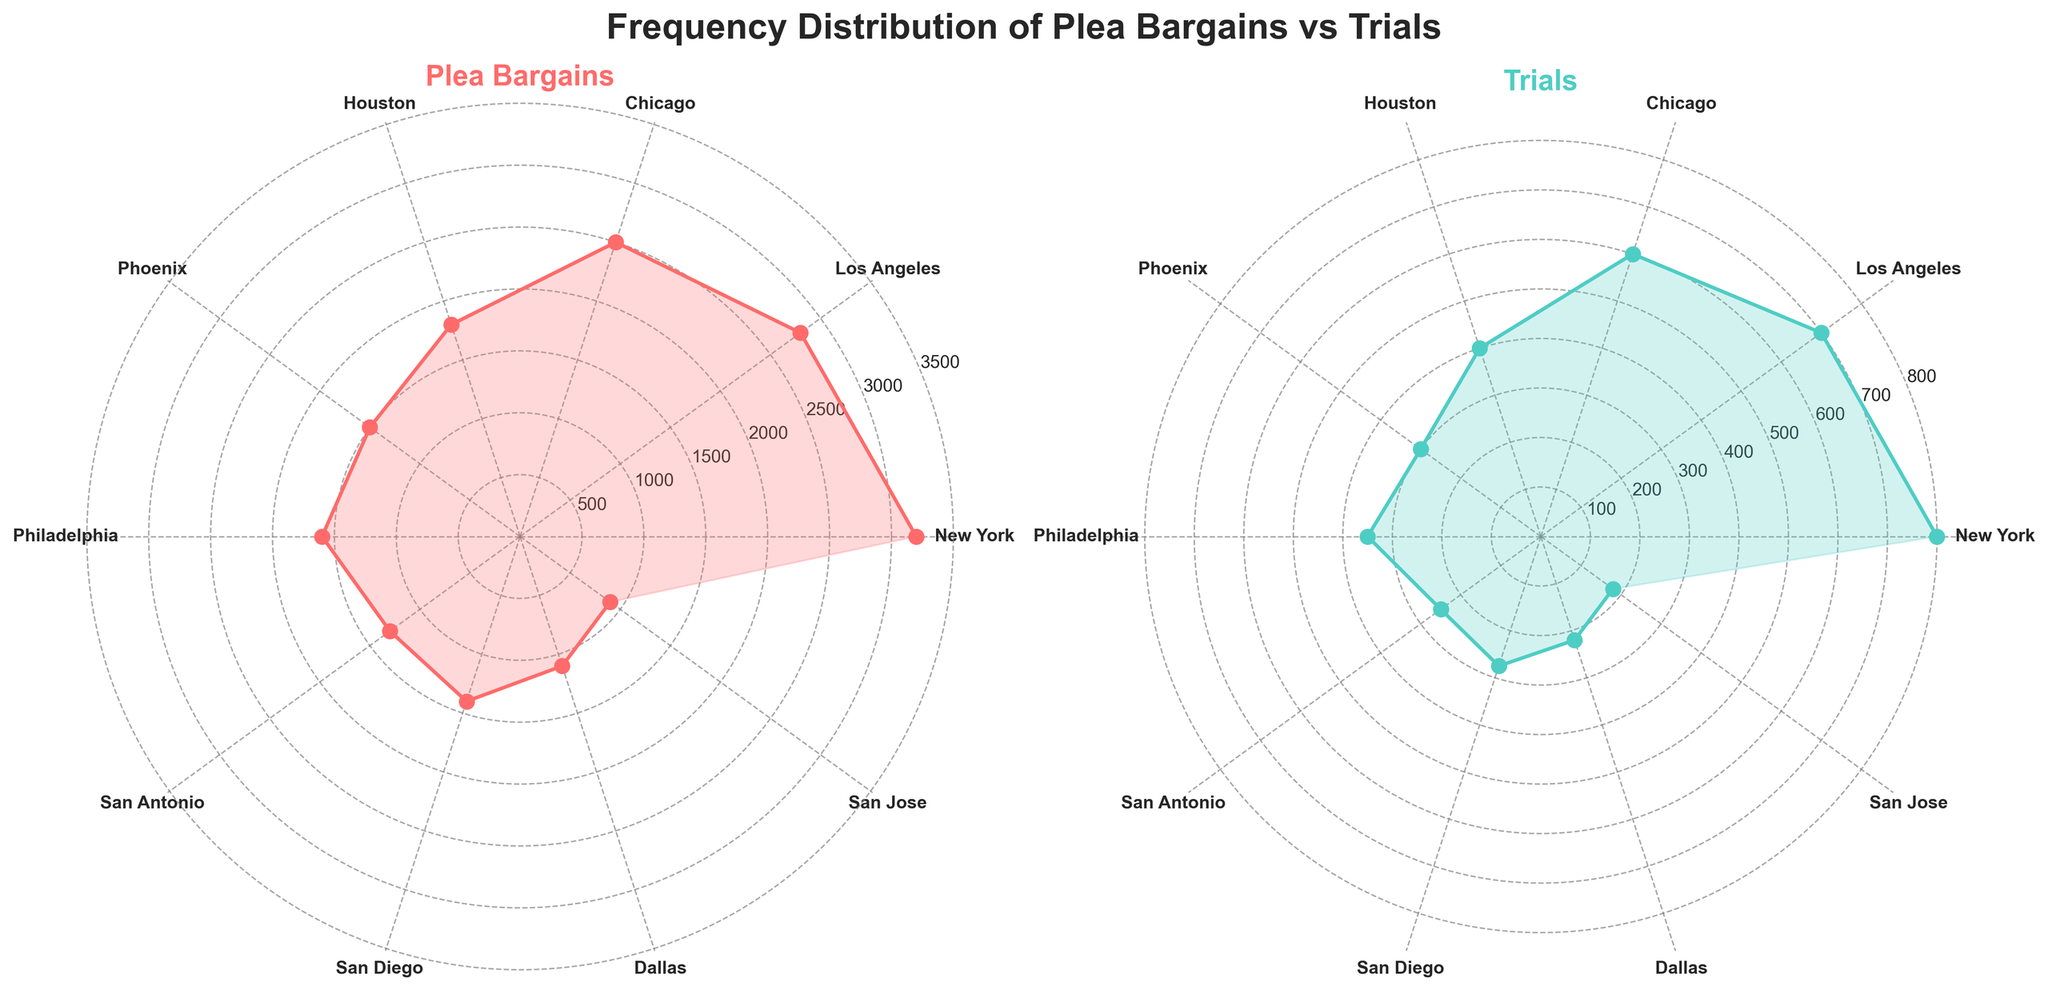What's the title of the figure? The title of the figure is prominently displayed at the top. It normally summarizes the content of the entire plot.
Answer: Frequency Distribution of Plea Bargains vs Trials Which jurisdiction has the highest number of plea bargains? To find the jurisdiction with the highest number of plea bargains, look for the point that extends the farthest from the origin in the plot with the title 'Plea Bargains'.
Answer: New York How many trials are represented by the shortest data point in the 'Trials' plot? In the 'Trials' plot, the shortest point originates from the center and corresponds to the smallest value of trials.
Answer: San Jose with 180 trials What is the difference between the number of plea bargains in New York and Houston? The number of plea bargains in New York is 3200, and in Houston, it is 1800. The difference is calculated by subtracting the smaller value from the larger one. 3200 - 1800 = 1400.
Answer: 1400 Which jurisdiction has more plea bargains, Philadelphia or San Antonio? To compare plea bargains between Philadelphia and San Antonio, look at their respective distances from the origin in the 'Plea Bargains' plot.
Answer: Philadelphia Which jurisdiction shows a smaller difference between plea bargains and trials, Dallas or Phoenix? Calculate the difference for both jurisdictions: Dallas (1100 - 220 = 880), Phoenix (1500 - 300 = 1200). Dallas has a smaller difference.
Answer: Dallas Name the two jurisdictions that have the closest number of plea bargains. Find two points that have the shortest distance between them in the 'Plea Bargains' plot.
Answer: San Diego and Los Angeles What is the average number of plea bargains across all jurisdictions? Sum up all plea bargains and divide by the number of jurisdictions: (3200 + 2800 + 2500 + 1800 + 1500 + 1600 + 1300 + 1400 + 1100 + 900) / 10.
Answer: 1810 How many jurisdictions have more than 200 trials? Count the number of jurisdictions represented by points that are farther from the origin than 200 in the 'Trials' plot.
Answer: 7 In the 'Plea Bargains' plot, which jurisdiction has the second highest value? Identify the second farthest point from the origin in the 'Plea Bargains' plot by comparing distances visually.
Answer: Los Angeles 